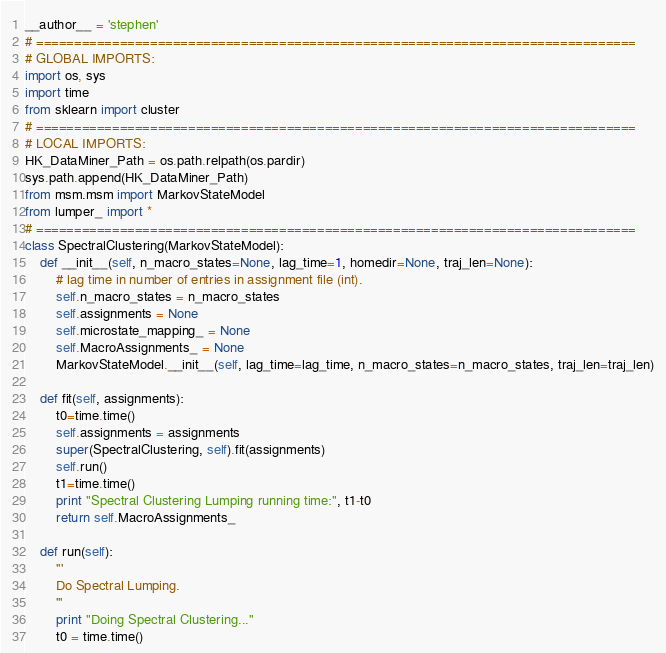<code> <loc_0><loc_0><loc_500><loc_500><_Python_>__author__ = 'stephen'
# ===============================================================================
# GLOBAL IMPORTS:
import os, sys
import time
from sklearn import cluster
# ===============================================================================
# LOCAL IMPORTS:
HK_DataMiner_Path = os.path.relpath(os.pardir)
sys.path.append(HK_DataMiner_Path)
from msm.msm import MarkovStateModel
from lumper_ import *
# ===============================================================================
class SpectralClustering(MarkovStateModel):
    def __init__(self, n_macro_states=None, lag_time=1, homedir=None, traj_len=None):
        # lag time in number of entries in assignment file (int).
        self.n_macro_states = n_macro_states
        self.assignments = None
        self.microstate_mapping_ = None
        self.MacroAssignments_ = None
        MarkovStateModel.__init__(self, lag_time=lag_time, n_macro_states=n_macro_states, traj_len=traj_len)

    def fit(self, assignments):
        t0=time.time()
        self.assignments = assignments
        super(SpectralClustering, self).fit(assignments)
        self.run()
        t1=time.time()
        print "Spectral Clustering Lumping running time:", t1-t0
        return self.MacroAssignments_

    def run(self):
        '''
        Do Spectral Lumping.
        '''
        print "Doing Spectral Clustering..."
        t0 = time.time()</code> 